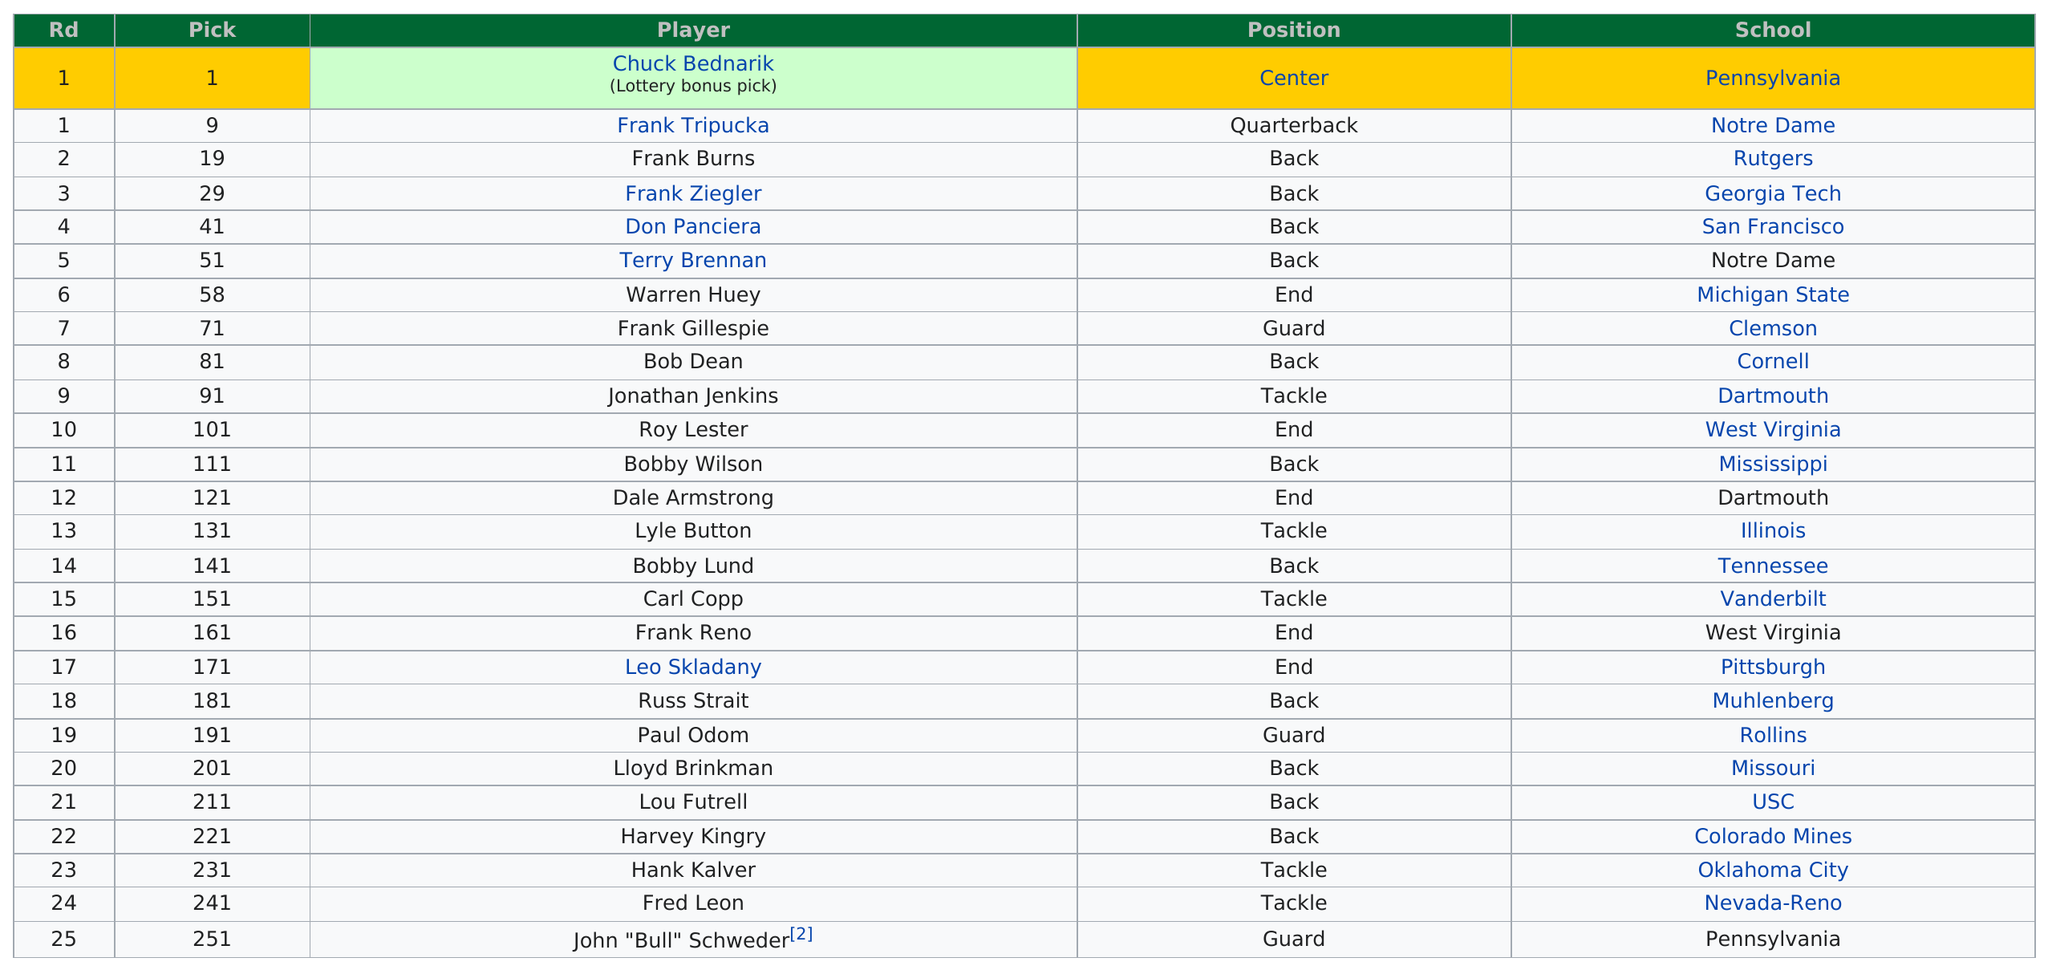Indicate a few pertinent items in this graphic. The highest RD number is 25. The most prevalent school is located in Pennsylvania. Out of the total number of players, two were from Notre Dame. The first draft pick was Chuck Bednarik or Frank Tripuka, and Chuck Bednarik was the first draft pick. The position that most of the players held was behind. 